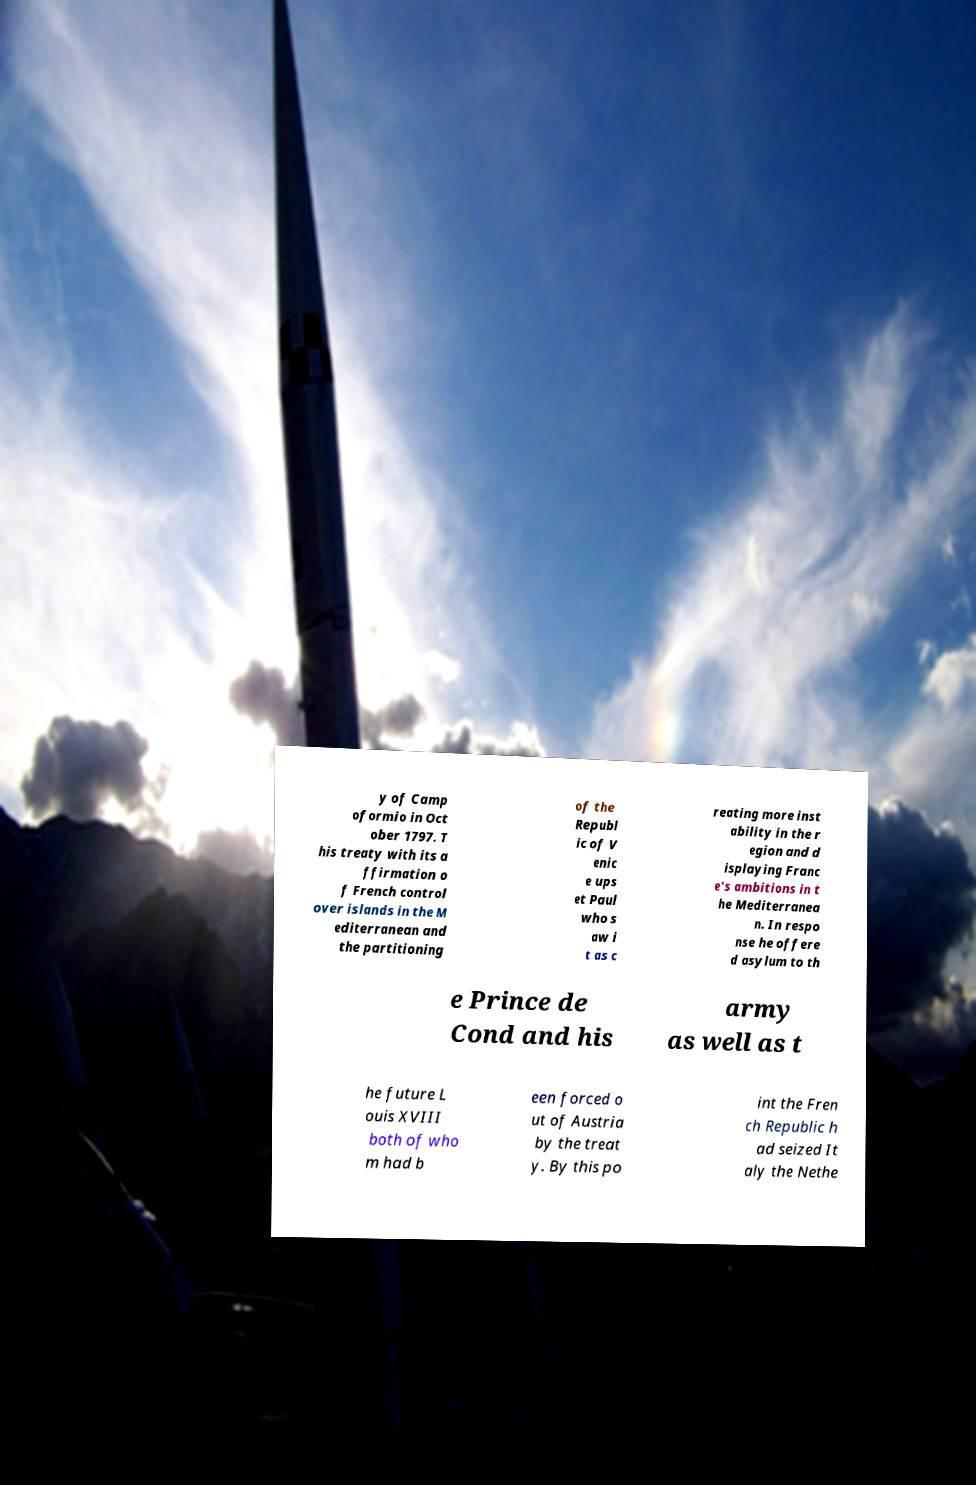I need the written content from this picture converted into text. Can you do that? y of Camp oformio in Oct ober 1797. T his treaty with its a ffirmation o f French control over islands in the M editerranean and the partitioning of the Republ ic of V enic e ups et Paul who s aw i t as c reating more inst ability in the r egion and d isplaying Franc e's ambitions in t he Mediterranea n. In respo nse he offere d asylum to th e Prince de Cond and his army as well as t he future L ouis XVIII both of who m had b een forced o ut of Austria by the treat y. By this po int the Fren ch Republic h ad seized It aly the Nethe 